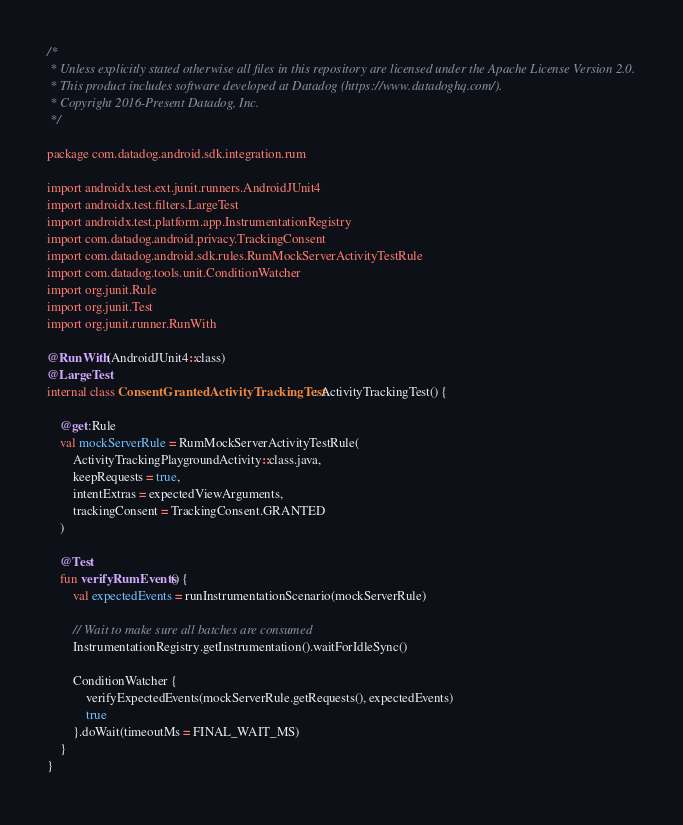<code> <loc_0><loc_0><loc_500><loc_500><_Kotlin_>/*
 * Unless explicitly stated otherwise all files in this repository are licensed under the Apache License Version 2.0.
 * This product includes software developed at Datadog (https://www.datadoghq.com/).
 * Copyright 2016-Present Datadog, Inc.
 */

package com.datadog.android.sdk.integration.rum

import androidx.test.ext.junit.runners.AndroidJUnit4
import androidx.test.filters.LargeTest
import androidx.test.platform.app.InstrumentationRegistry
import com.datadog.android.privacy.TrackingConsent
import com.datadog.android.sdk.rules.RumMockServerActivityTestRule
import com.datadog.tools.unit.ConditionWatcher
import org.junit.Rule
import org.junit.Test
import org.junit.runner.RunWith

@RunWith(AndroidJUnit4::class)
@LargeTest
internal class ConsentGrantedActivityTrackingTest : ActivityTrackingTest() {

    @get:Rule
    val mockServerRule = RumMockServerActivityTestRule(
        ActivityTrackingPlaygroundActivity::class.java,
        keepRequests = true,
        intentExtras = expectedViewArguments,
        trackingConsent = TrackingConsent.GRANTED
    )

    @Test
    fun verifyRumEvents() {
        val expectedEvents = runInstrumentationScenario(mockServerRule)

        // Wait to make sure all batches are consumed
        InstrumentationRegistry.getInstrumentation().waitForIdleSync()

        ConditionWatcher {
            verifyExpectedEvents(mockServerRule.getRequests(), expectedEvents)
            true
        }.doWait(timeoutMs = FINAL_WAIT_MS)
    }
}
</code> 